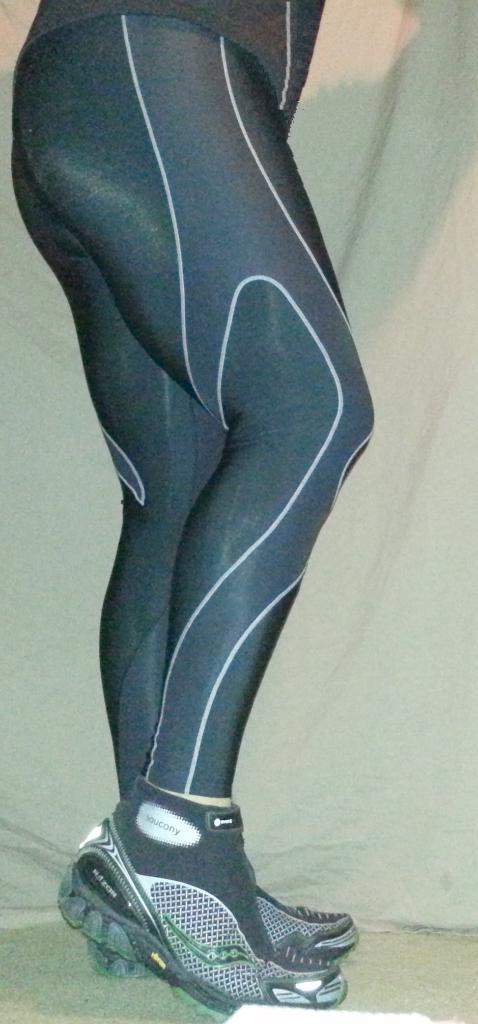What part of a person's body can be seen in the image? There are legs visible in the image. What type of footwear is the person wearing? The person is wearing shoes. What type of train can be seen in the image? There is no train present in the image; it only features legs and shoes. 